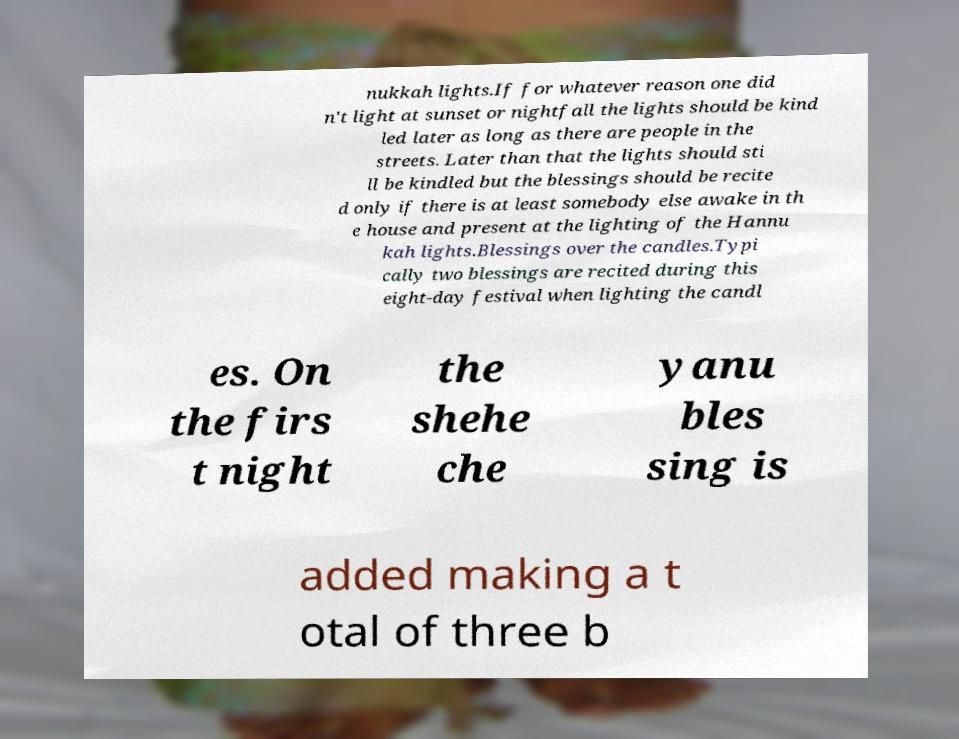Please read and relay the text visible in this image. What does it say? nukkah lights.If for whatever reason one did n't light at sunset or nightfall the lights should be kind led later as long as there are people in the streets. Later than that the lights should sti ll be kindled but the blessings should be recite d only if there is at least somebody else awake in th e house and present at the lighting of the Hannu kah lights.Blessings over the candles.Typi cally two blessings are recited during this eight-day festival when lighting the candl es. On the firs t night the shehe che yanu bles sing is added making a t otal of three b 